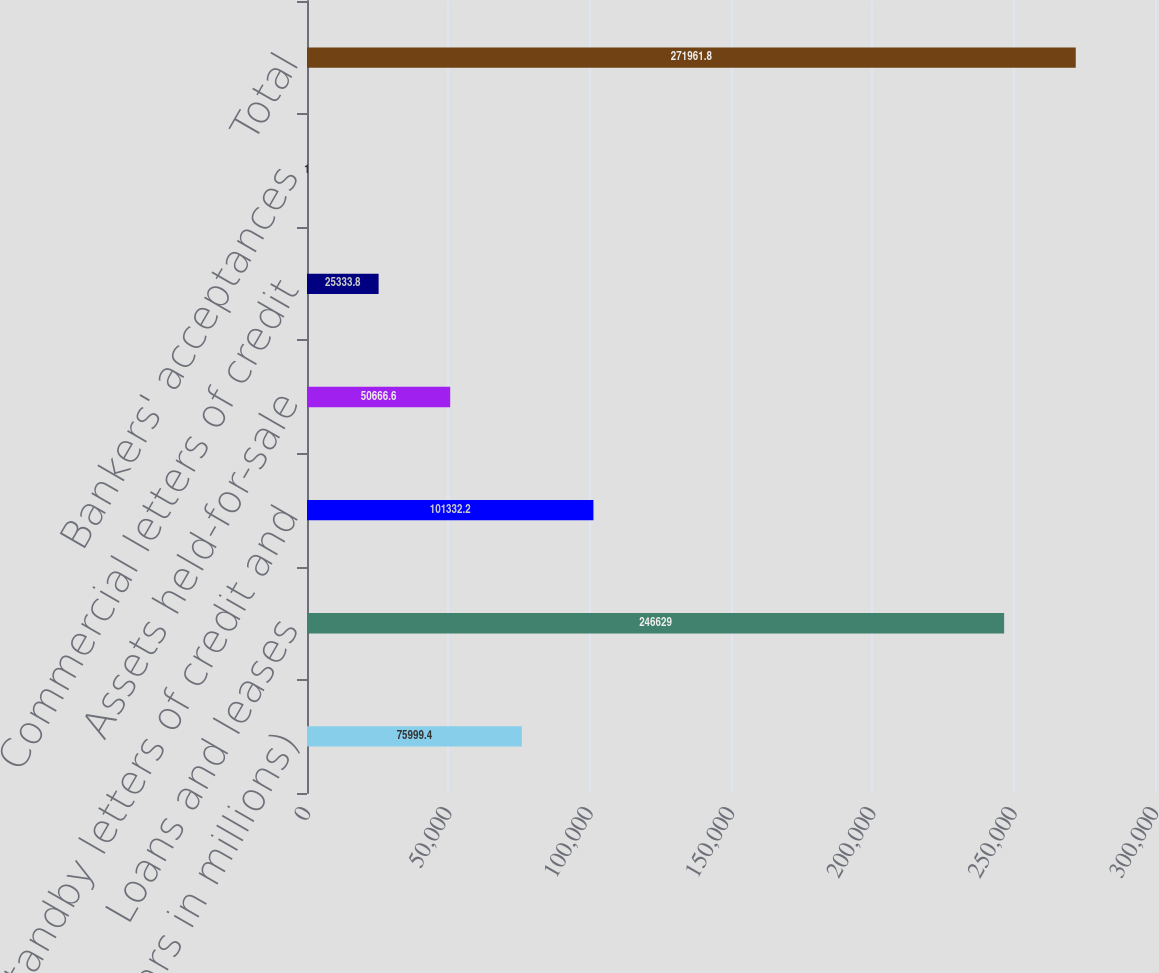Convert chart. <chart><loc_0><loc_0><loc_500><loc_500><bar_chart><fcel>(Dollars in millions)<fcel>Loans and leases<fcel>Standby letters of credit and<fcel>Assets held-for-sale<fcel>Commercial letters of credit<fcel>Bankers' acceptances<fcel>Total<nl><fcel>75999.4<fcel>246629<fcel>101332<fcel>50666.6<fcel>25333.8<fcel>1<fcel>271962<nl></chart> 